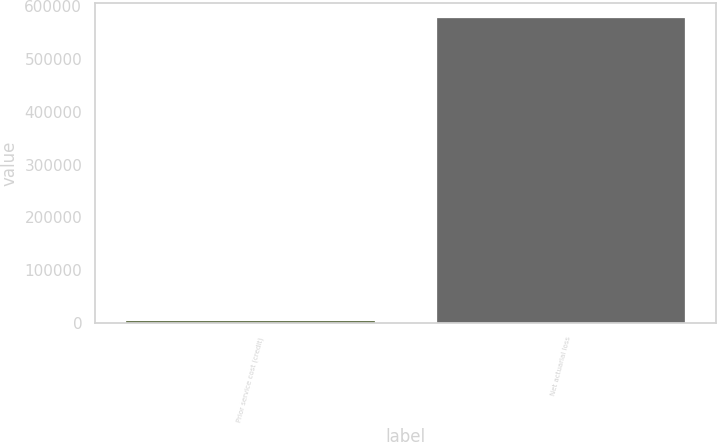<chart> <loc_0><loc_0><loc_500><loc_500><bar_chart><fcel>Prior service cost (credit)<fcel>Net actuarial loss<nl><fcel>3489<fcel>577140<nl></chart> 